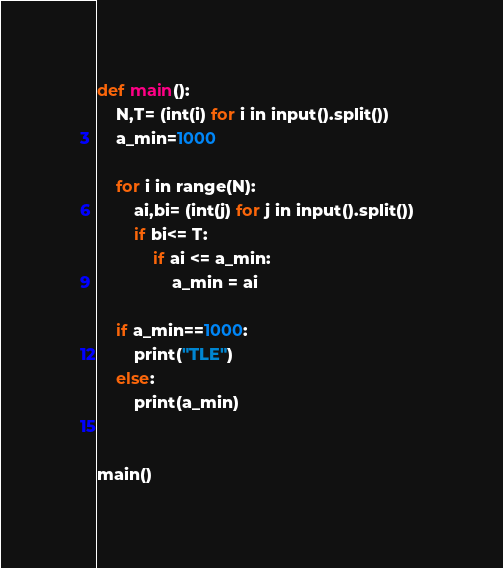Convert code to text. <code><loc_0><loc_0><loc_500><loc_500><_Python_>def main():
    N,T= (int(i) for i in input().split())
    a_min=1000

    for i in range(N):
        ai,bi= (int(j) for j in input().split())  
        if bi<= T:
            if ai <= a_min:
                a_min = ai

    if a_min==1000:
        print("TLE")
    else:
        print(a_min)
          
     
main()</code> 